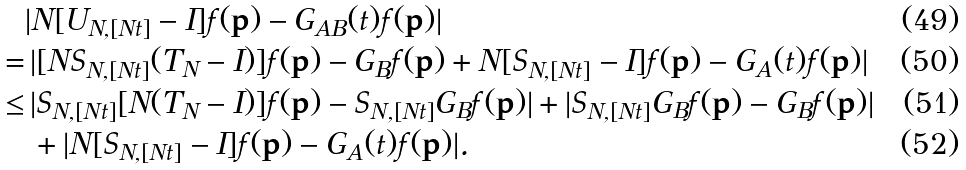Convert formula to latex. <formula><loc_0><loc_0><loc_500><loc_500>{ } & | N [ U _ { N , [ N t ] } - I ] f ( { \mathbf p } ) - G _ { A B } ( t ) f ( { \mathbf p } ) | \\ = & \, | [ N S _ { N , [ N t ] } ( T _ { N } - I ) ] f ( { \mathbf p } ) - G _ { B } f ( { \mathbf p } ) + N [ S _ { N , [ N t ] } - I ] f ( { \mathbf p } ) - G _ { A } ( t ) f ( { \mathbf p } ) | \\ \leq & \, | S _ { N , [ N t ] } [ N ( T _ { N } - I ) ] f ( { \mathbf p } ) - S _ { N , [ N t ] } G _ { B } f ( { \mathbf p } ) | + | S _ { N , [ N t ] } G _ { B } f ( { \mathbf p } ) - G _ { B } f ( { \mathbf p } ) | \\ & \, + | N [ S _ { N , [ N t ] } - I ] f ( { \mathbf p } ) - G _ { A } ( t ) f ( { \mathbf p } ) | .</formula> 